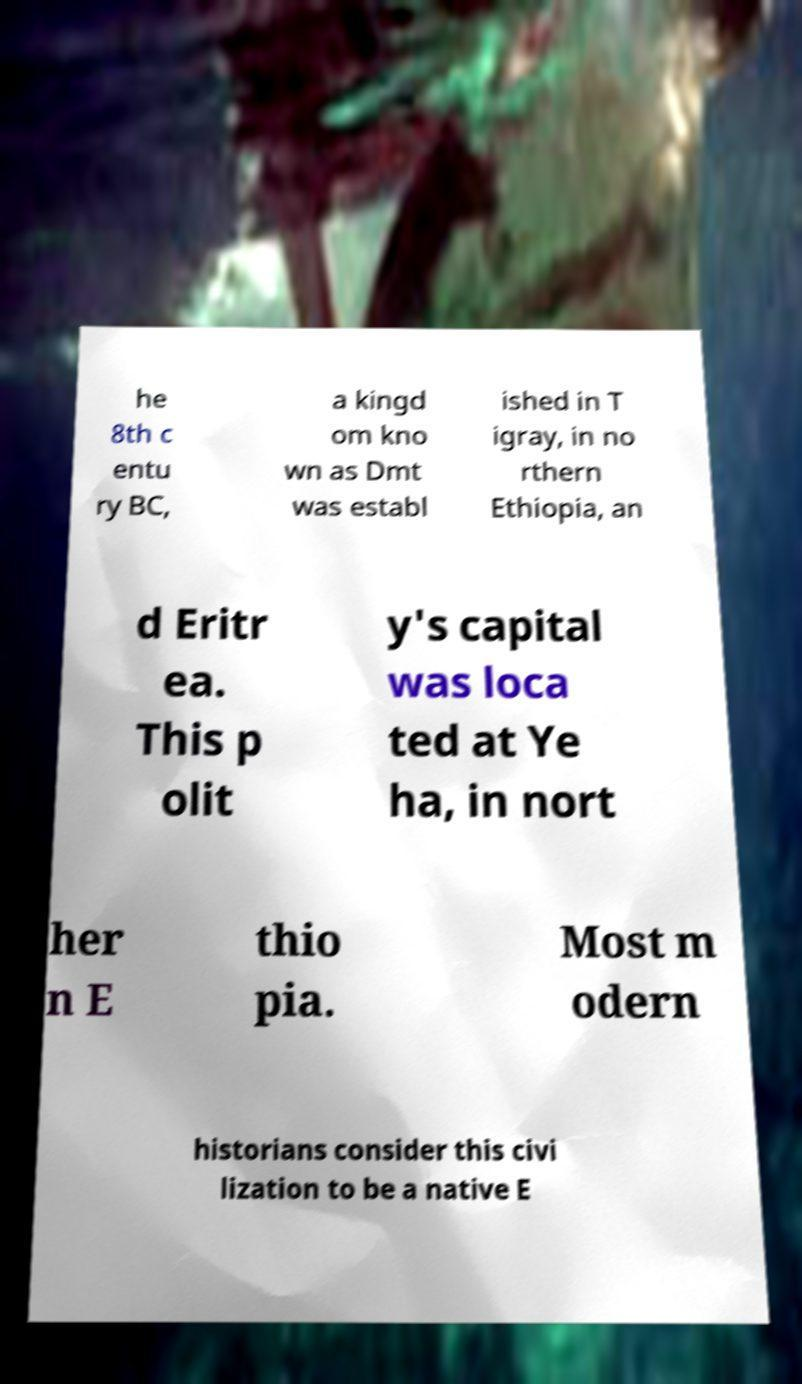Could you extract and type out the text from this image? he 8th c entu ry BC, a kingd om kno wn as Dmt was establ ished in T igray, in no rthern Ethiopia, an d Eritr ea. This p olit y's capital was loca ted at Ye ha, in nort her n E thio pia. Most m odern historians consider this civi lization to be a native E 